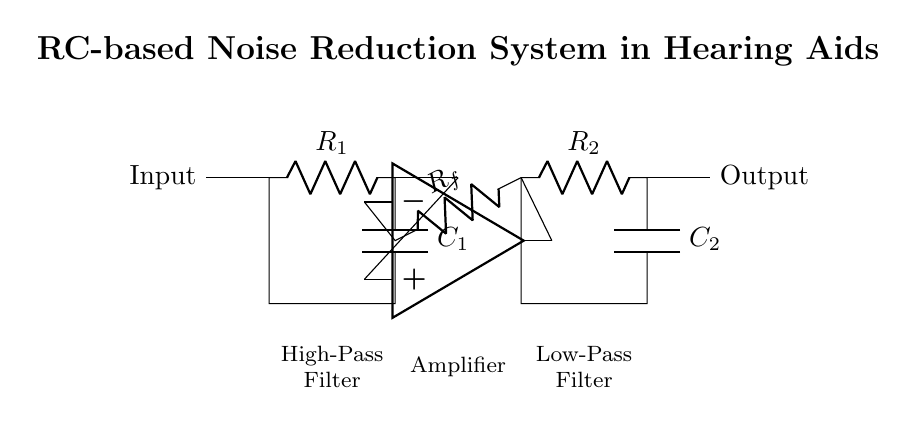What are the main components in this circuit? The main components in the circuit are resistors and capacitors. The circuit includes a resistor labeled R1, a capacitor labeled C1 for the high-pass filter, another resistor R2, and a capacitor C2 for the low-pass filter.
Answer: resistors and capacitors What is the function of the high-pass filter in this circuit? The high-pass filter, made up of R1 and C1, allows signals with a frequency higher than a certain cutoff frequency to pass while attenuating lower-frequency signals. This helps to reduce low-frequency noise in hearing aids.
Answer: reduce low-frequency noise How many filters are present in the circuit? The circuit includes two filters: a high-pass filter and a low-pass filter. The high-pass filter is connected before the amplifier, and the low-pass filter is connected after the amplifier.
Answer: two filters What is the role of the op-amp in this circuit? The op-amp, located between the high-pass and low-pass filters, serves as an amplifier that increases the signal gain. It takes the filtered audio signal and boosts it for better clarity in communication.
Answer: amplifier What happens to the signal after passing through the low-pass filter? After passing through the low-pass filter, the signal is further reduced of high-frequency noise, allowing for a clearer output signal. The output is sent to the hearing aid speaker for clear sound reproduction.
Answer: clearer output signal Which component provides feedback in this circuit? The feedback in this circuit is provided by the resistor Rf that is connected from the output of the op-amp back to its inverting input, which helps control the gain of the amplifier.
Answer: resistor Rf 